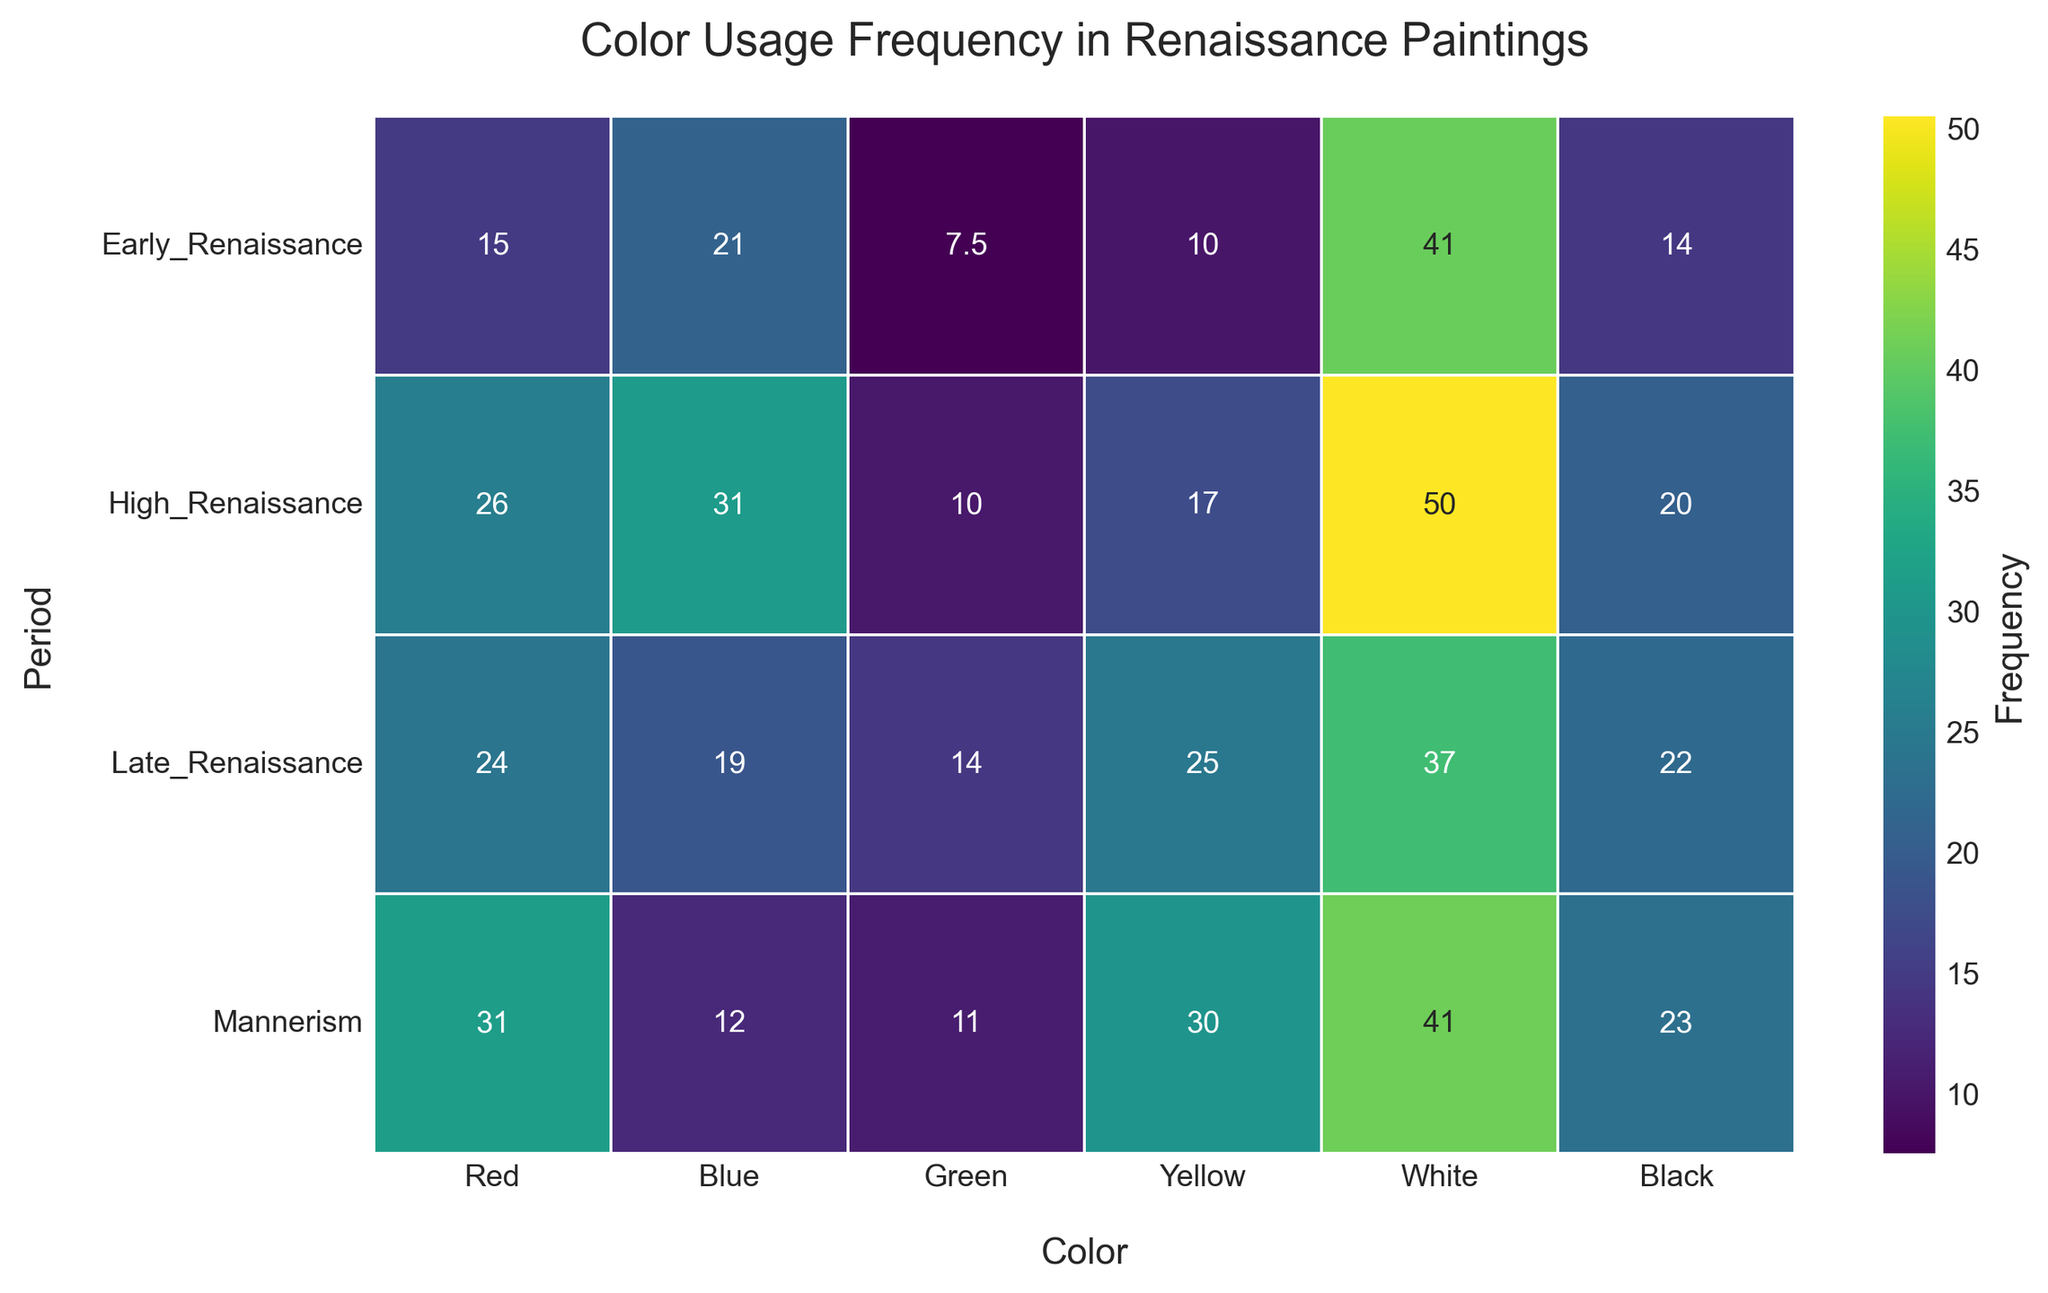What is the average frequency of the color Red in the High Renaissance period? First, find all values for Red in the High Renaissance period: 25, 28, 26, 24. Then, sum these values: 25 + 28 + 26 + 24 = 103, and finally, divide by the number of data points: 103 / 4 = 25.75
Answer: 25.75 In which period is the frequency of Yellow the highest? Observe the heatmap and look for the cell with the highest frequency value in the Yellow column. The highest value is 30, found in the Mannerism period.
Answer: Mannerism Which color has the lowest average frequency in the Early Renaissance period? Check the average frequencies for each color in the Early Renaissance row. The color Green has the lowest value at 7.5.
Answer: Green How does the average frequency of Blue in the Late Renaissance period compare to that in the Mannerism period? Look at the average frequencies for Blue in both periods. Late Renaissance has an average Blue frequency of 19, while Mannerism has an average Blue frequency of 12. Therefore, Blue is more frequent in the Late Renaissance.
Answer: Late Renaissance Is the average frequency of Black higher in the High Renaissance or the Early Renaissance period? Compare the average values for Black in both periods. The High Renaissance has an average of 20.5, and the Early Renaissance has an average of 14.25. Therefore, the average is higher in the High Renaissance.
Answer: High Renaissance What is the total average frequency of all colors combined in the Mannerism period? Find the average values for each color in the Mannerism period: Red (31.25), Blue (12.5), Green (11), Yellow (29.75), White (41), Black (23.25). Sum these averages: 31.25 + 12.5 + 11 + 29.75 + 41 + 23.25 = 148.75
Answer: 148.75 